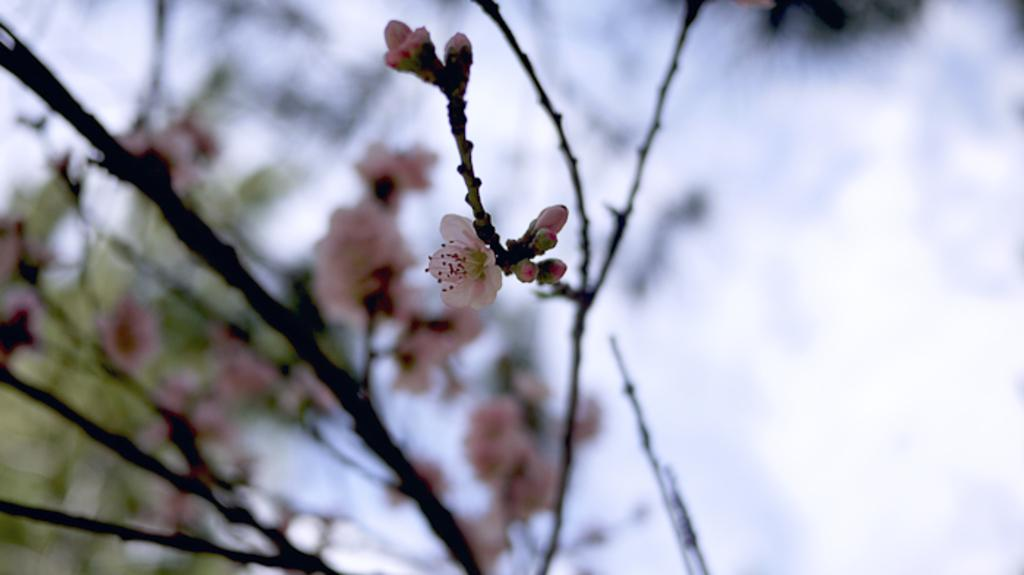What type of living organisms can be seen in the image? Plants and flowers can be seen in the image. Can you describe the flowers in the image? Yes, there are flowers in the image. What type of bun can be seen in the image? There is no bun present in the image. Is the store open for business in the image? There is no store present in the image. Can you see the moon in the image? There is no moon present in the image. 